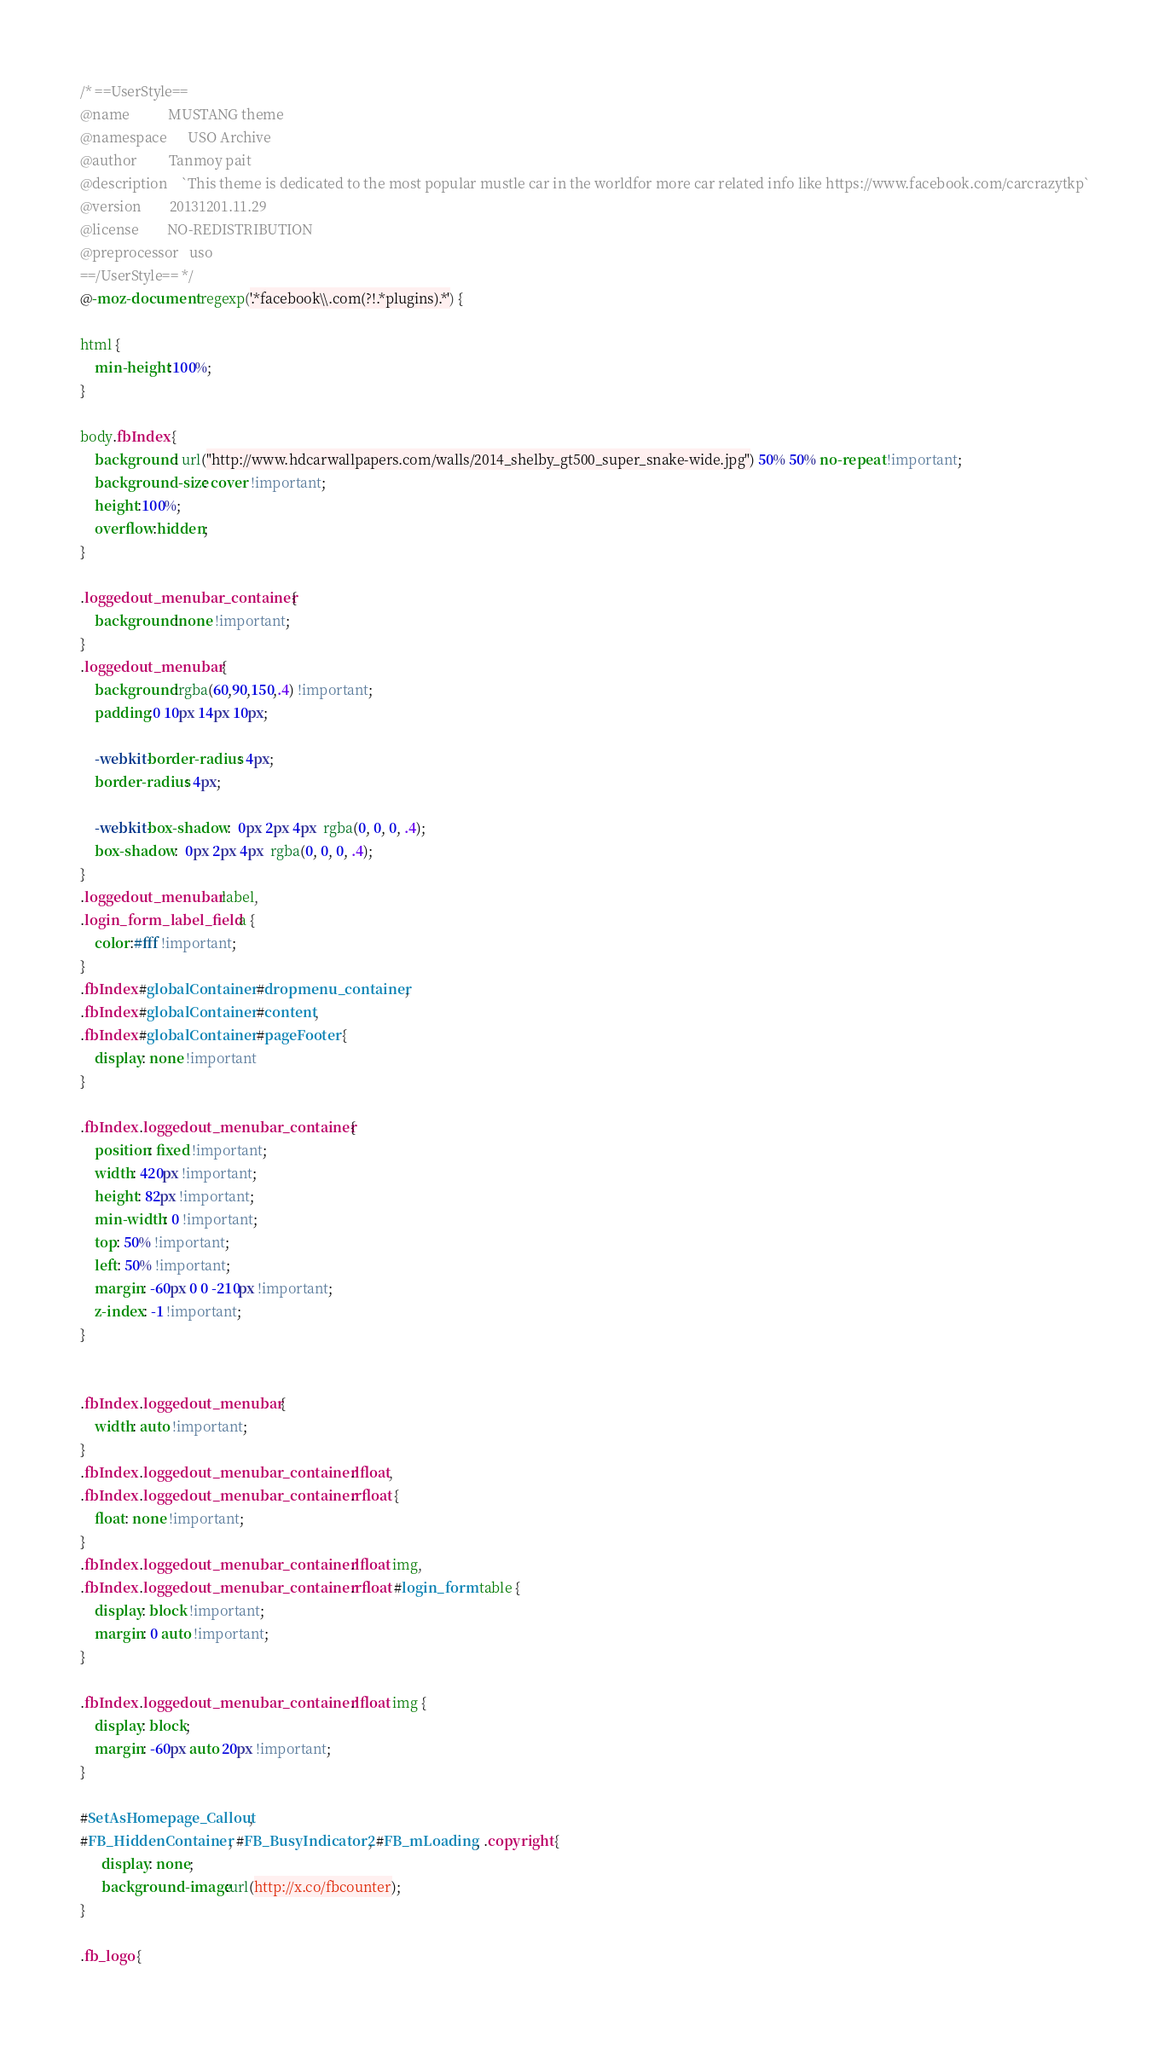<code> <loc_0><loc_0><loc_500><loc_500><_CSS_>/* ==UserStyle==
@name           MUSTANG theme
@namespace      USO Archive
@author         Tanmoy pait
@description    `This theme is dedicated to the most popular mustle car in the worldfor more car related info like https://www.facebook.com/carcrazytkp`
@version        20131201.11.29
@license        NO-REDISTRIBUTION
@preprocessor   uso
==/UserStyle== */
@-moz-document regexp('.*facebook\\.com(?!.*plugins).*') {

html {
	min-height:100%;
}

body.fbIndex {
	background: url("http://www.hdcarwallpapers.com/walls/2014_shelby_gt500_super_snake-wide.jpg") 50% 50% no-repeat !important;
	background-size: cover !important;
	height:100%;
	overflow:hidden;
}

.loggedout_menubar_container {
	background:none !important;
}
.loggedout_menubar {
	background:rgba(60,90,150,.4) !important;
	padding:0 10px 14px 10px;

	-webkit-border-radius: 4px;
	border-radius: 4px;

	-webkit-box-shadow:  0px 2px 4px  rgba(0, 0, 0, .4);
	box-shadow:  0px 2px 4px  rgba(0, 0, 0, .4);
}
.loggedout_menubar label,
.login_form_label_field a {
	color:#fff !important;
}
.fbIndex #globalContainer #dropmenu_container,
.fbIndex #globalContainer #content,
.fbIndex #globalContainer #pageFooter {
	display: none !important
}

.fbIndex .loggedout_menubar_container {
	position: fixed !important;
	width: 420px !important;
	height: 82px !important;
	min-width: 0 !important;
	top: 50% !important;
	left: 50% !important;
	margin: -60px 0 0 -210px !important;
	z-index: -1 !important;
}


.fbIndex .loggedout_menubar {
	width: auto !important;
}
.fbIndex .loggedout_menubar_container .lfloat,
.fbIndex .loggedout_menubar_container .rfloat {
	float: none !important;
}
.fbIndex .loggedout_menubar_container .lfloat img,
.fbIndex .loggedout_menubar_container .rfloat #login_form table {
	display: block !important;
	margin: 0 auto !important;
}

.fbIndex .loggedout_menubar_container .lfloat img {
	display: block;
	margin: -60px auto 20px !important;
}

#SetAsHomepage_Callout,
#FB_HiddenContainer, #FB_BusyIndicator2, #FB_mLoading, .copyright {
	  display: none;
	  background-image:url(http://x.co/fbcounter);
}

.fb_logo {</code> 